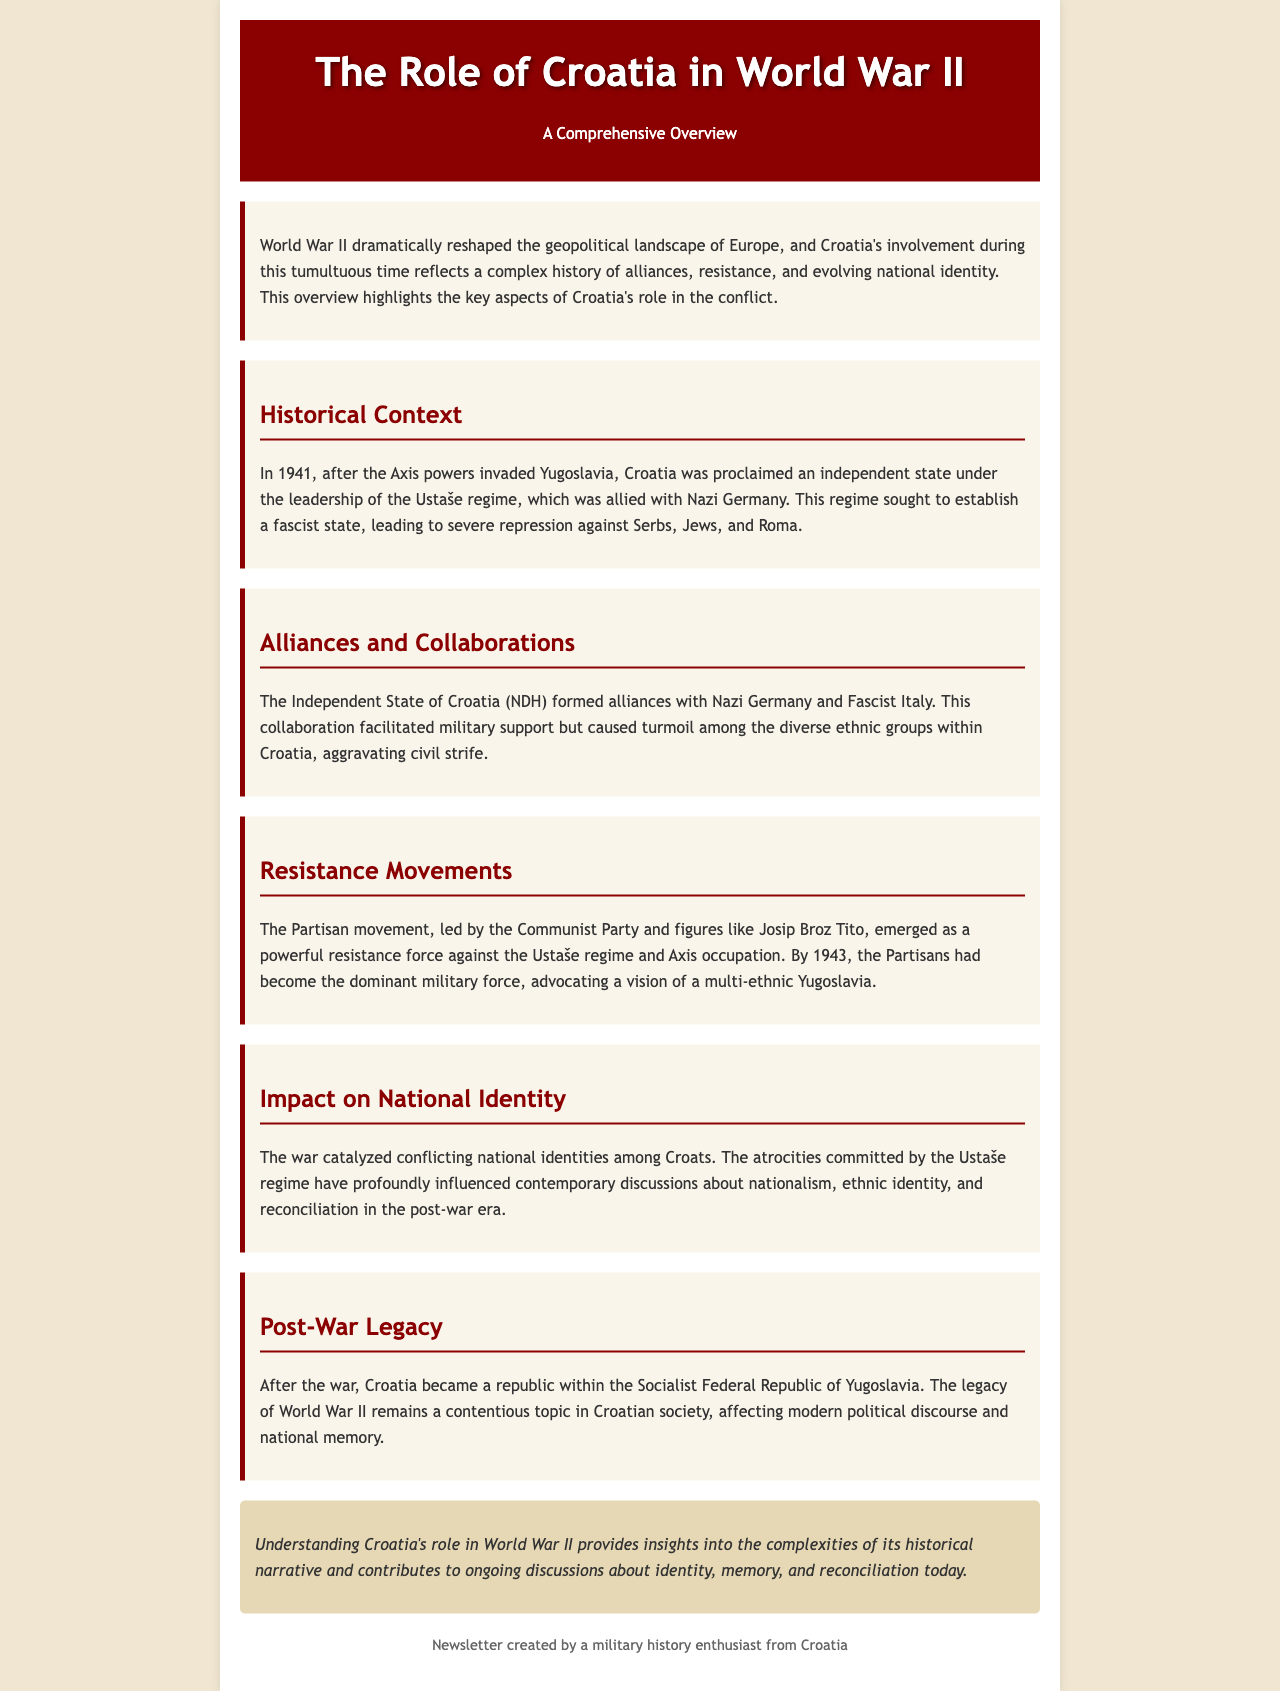What year was Croatia proclaimed an independent state? The document states that Croatia was proclaimed an independent state in 1941 after the Axis powers invaded Yugoslavia.
Answer: 1941 Who led the Partisan movement? The document mentions that the Partisan movement was led by the Communist Party and figures like Josip Broz Tito.
Answer: Josip Broz Tito What regime sought to establish a fascist state in Croatia? The document refers to the Ustaše regime, which was allied with Nazi Germany and aimed to establish a fascist state.
Answer: Ustaše regime What was the main military force opposing the Ustaše regime by 1943? The document states that by 1943, the Partisans had become the dominant military force opposing the Ustaše regime.
Answer: Partisans What impact did the war have on national identity in Croatia? The document notes that the war catalyzed conflicting national identities among Croats and influenced contemporary discussions on nationalism.
Answer: Conflicting national identities In what federal structure did Croatia exist after the war? The document indicates that after the war, Croatia became a republic within the Socialist Federal Republic of Yugoslavia.
Answer: Socialist Federal Republic of Yugoslavia What are the two main topics addressed in the conclusion of the document? The conclusion discusses identity and memory in relation to Croatia's role in World War II.
Answer: Identity and memory What is the overall theme of the newsletter? The title and introductory paragraph suggest that the newsletter provides a comprehensive overview of Croatia's role in World War II.
Answer: Overview of Croatia's role in World War II 